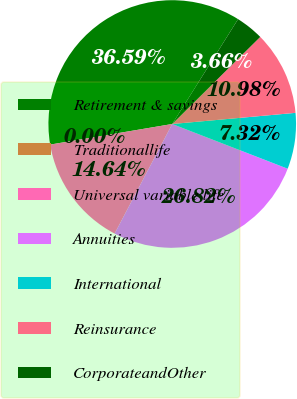<chart> <loc_0><loc_0><loc_500><loc_500><pie_chart><fcel>Retirement & savings<fcel>Traditionallife<fcel>Universal variable life<fcel>Annuities<fcel>International<fcel>Reinsurance<fcel>CorporateandOther<nl><fcel>36.59%<fcel>0.0%<fcel>14.64%<fcel>26.82%<fcel>7.32%<fcel>10.98%<fcel>3.66%<nl></chart> 